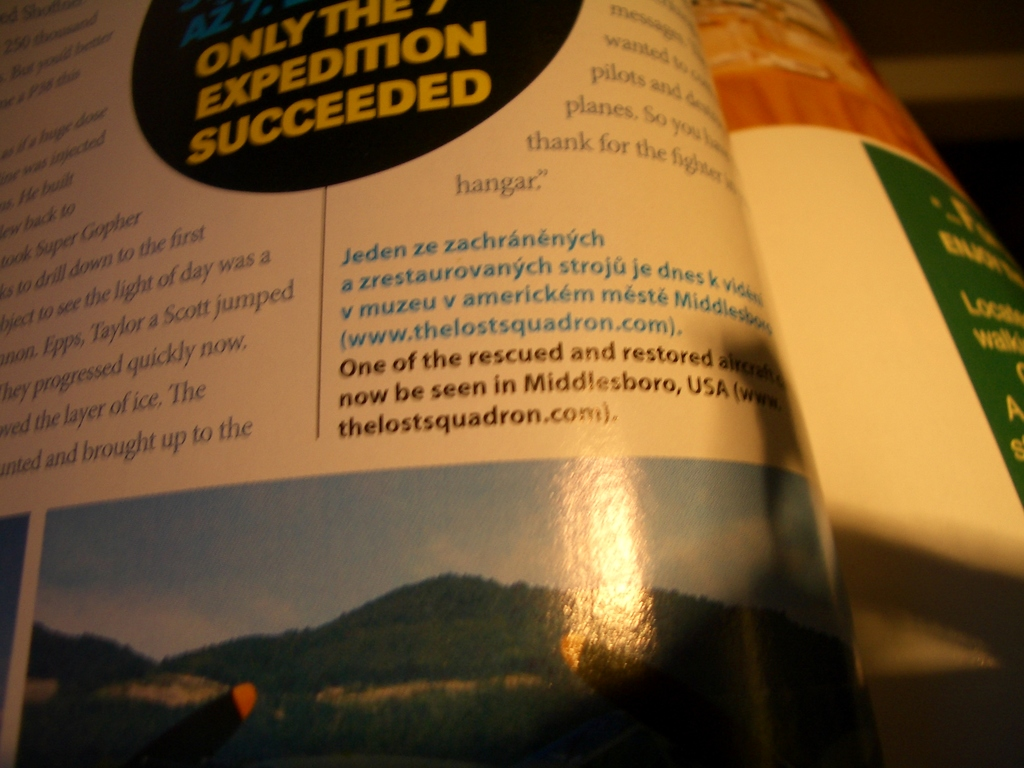Provide a one-sentence caption for the provided image. A glimpse into aviation history: the image shows text describing the successful seventh expedition alongside a restored airplane now displayed in Middlesboro, USA museum. 